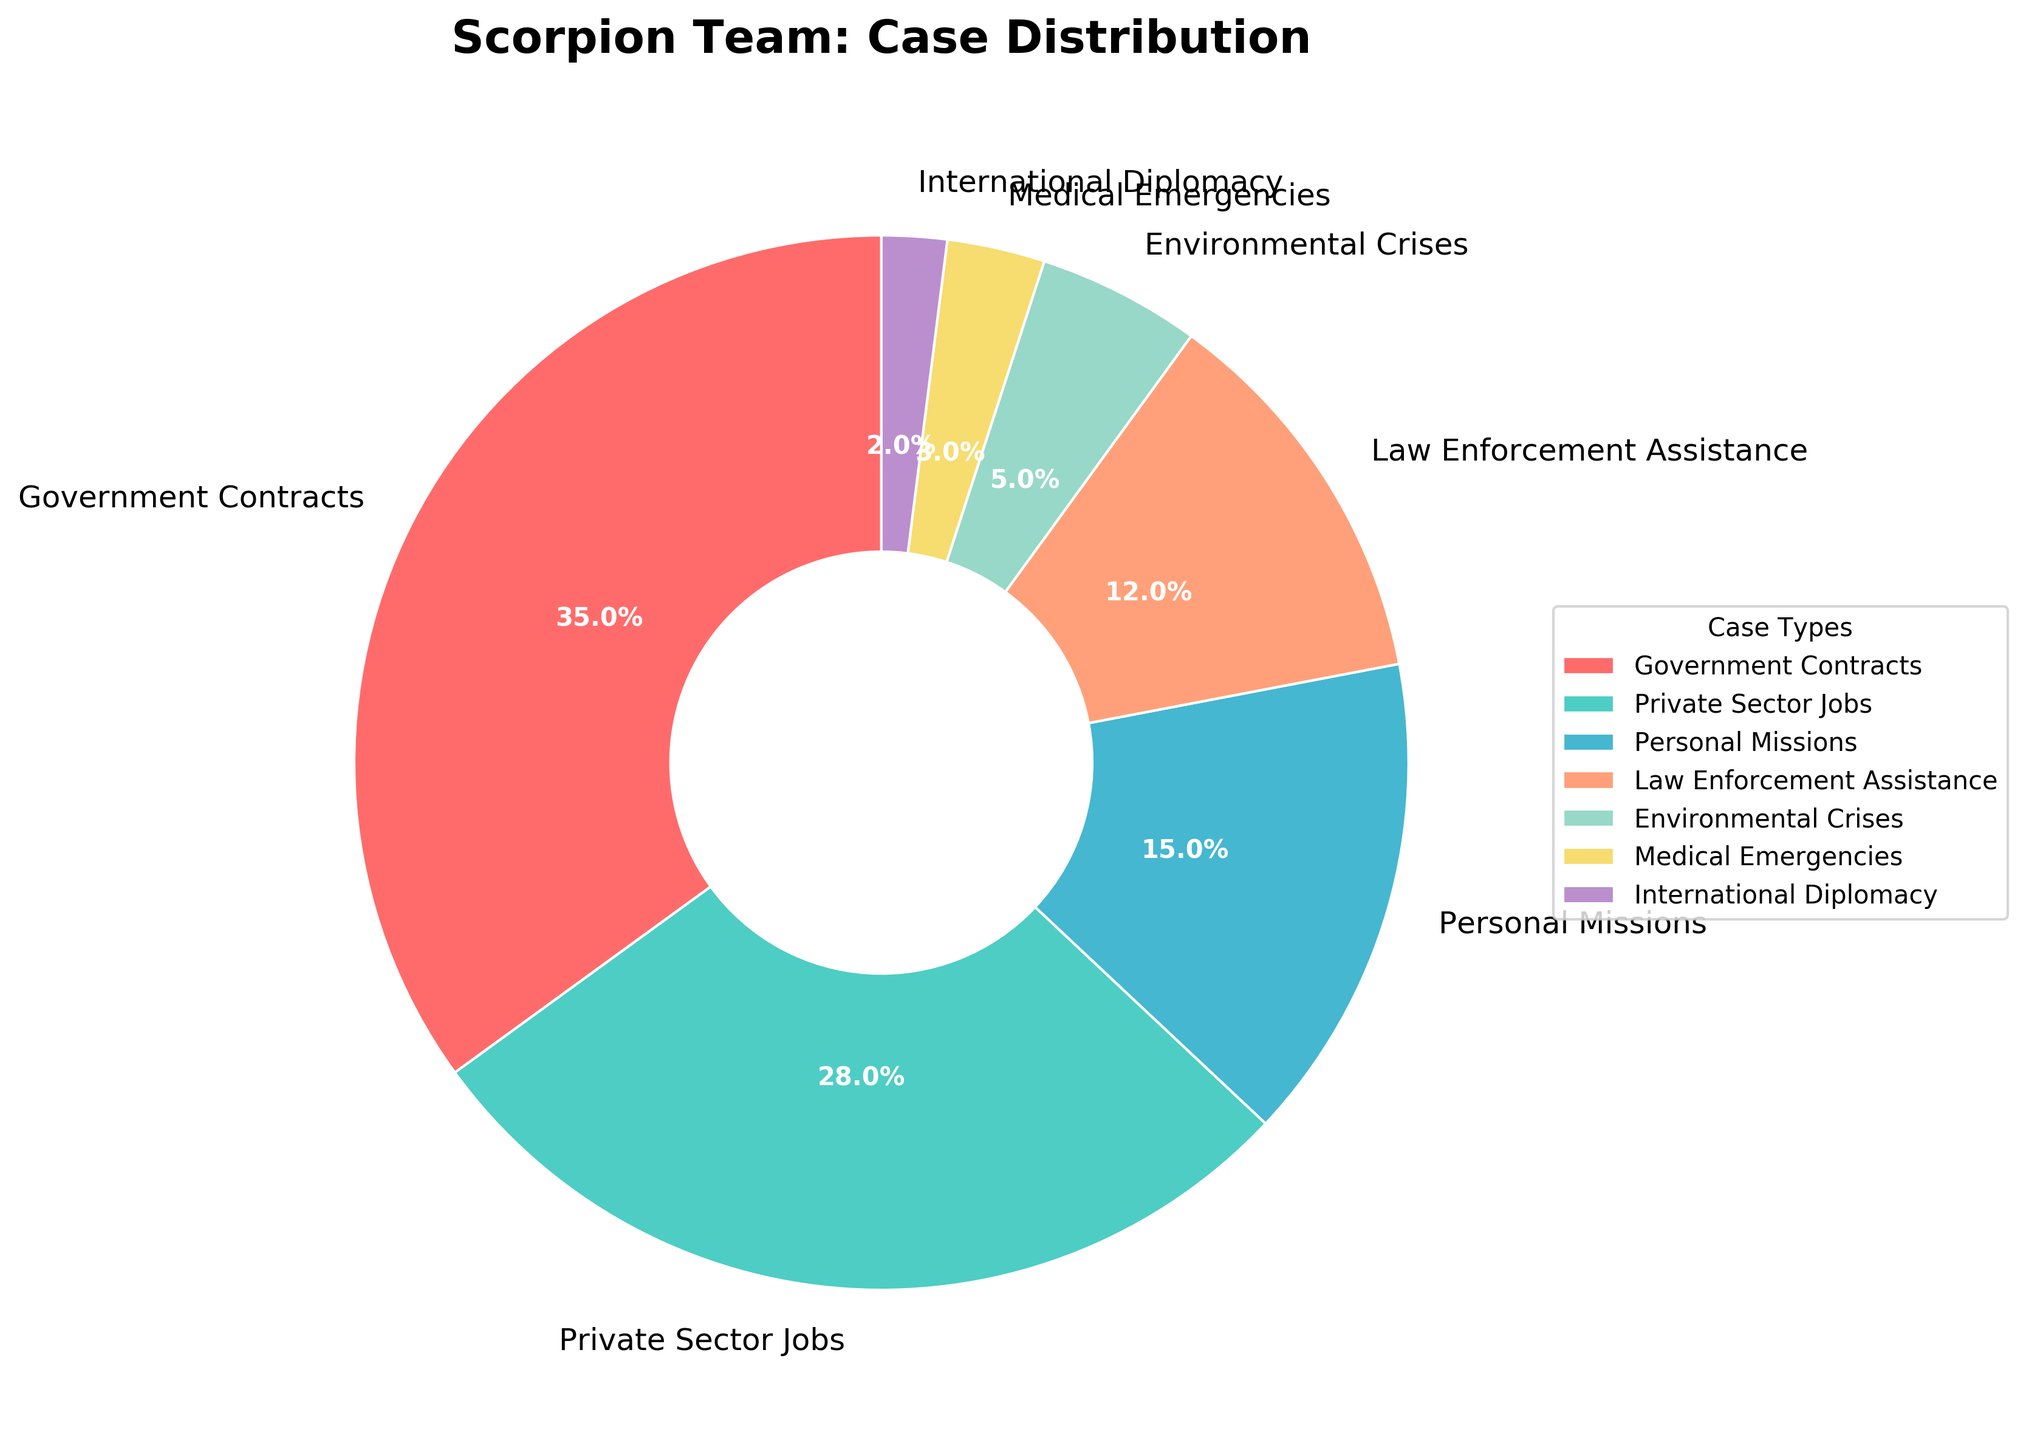What's the most common type of case solved by the Scorpion team? The pie chart shows each case type segment with its corresponding percentage. The segment with the largest percentage represents the most common type of case. "Government Contracts" has the highest percentage of 35%.
Answer: Government Contracts How much more common are Government Contracts than Medical Emergencies cases? The percentage for Government Contracts is 35% and for Medical Emergencies is 3%. To find how much more common, subtract 3% from 35%. 35% - 3% = 32%.
Answer: 32% What's the total percentage of cases solved in the private sector and personal missions combined? The percentage for Private Sector Jobs is 28% and for Personal Missions is 15%. Adding them gives 28% + 15% = 43%.
Answer: 43% Which case type is represented by a segment that is colored green? The pie chart segment for "Private Sector Jobs" is green. This can be identified by matching the label and corresponding color in the chart's legend.
Answer: Private Sector Jobs Is the combined proportion of Environmental Crises and International Diplomacy cases greater than 7%? Environmental Crises have a percentage of 5% and International Diplomacy has 2%. Adding them gives 5% + 2% = 7%. Therefore, they are not greater than 7%, but equal.
Answer: No (They are equal) What case types have smaller proportions than Law Enforcement Assistance? In the pie chart, Law Enforcement Assistance is 12%. The case types with smaller proportions are Environmental Crises (5%), Medical Emergencies (3%), and International Diplomacy (2%).
Answer: Environmental Crises, Medical Emergencies, International Diplomacy By how much does the proportion of Law Enforcement Assistance exceed the proportion of Environmental Crises? The percentage for Law Enforcement Assistance is 12% and for Environmental Crises is 5%. Subtract 5% from 12% to find the excess. 12% - 5% = 7%.
Answer: 7% What's the ratio of Government Contracts to Environmental Crises cases? The percentage for Government Contracts is 35% and for Environmental Crises is 5%. The ratio is 35:5, which simplifies to 7:1.
Answer: 7:1 Are Medical Emergencies less frequent than International Diplomacy based on the pie chart? The percentage for Medical Emergencies is 3% and for International Diplomacy is 2%. Therefore, Medical Emergencies occur more frequently than International Diplomacy.
Answer: No 